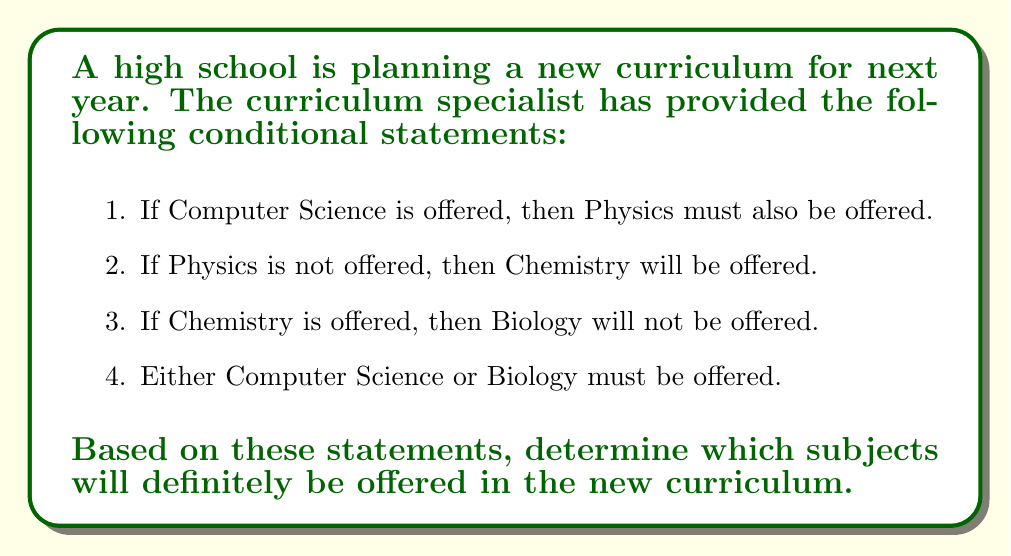Could you help me with this problem? Let's approach this step-by-step using logical reasoning:

1. We start with the fourth statement: Either Computer Science or Biology must be offered. This means we have two initial possibilities:

   Case A: Computer Science is offered
   Case B: Biology is offered

2. Let's explore Case A first:
   If Computer Science is offered, then according to statement 1, Physics must also be offered.
   
   $CS \Rightarrow Physics$

3. Now, let's consider Case B:
   If Biology is offered, then according to statement 3, Chemistry cannot be offered.
   
   $Biology \Rightarrow \neg Chemistry$

   If Chemistry is not offered, then according to statement 2, Physics must be offered.
   
   $\neg Chemistry \Rightarrow Physics$

4. We can see that in both cases, Physics must be offered. This is our definite conclusion.

5. We cannot determine for certain whether Computer Science, Biology, or Chemistry will be offered because there are still multiple possibilities that satisfy all the conditions.

Therefore, the only subject we can definitively say will be offered is Physics.
Answer: Physics will definitely be offered in the new curriculum. 